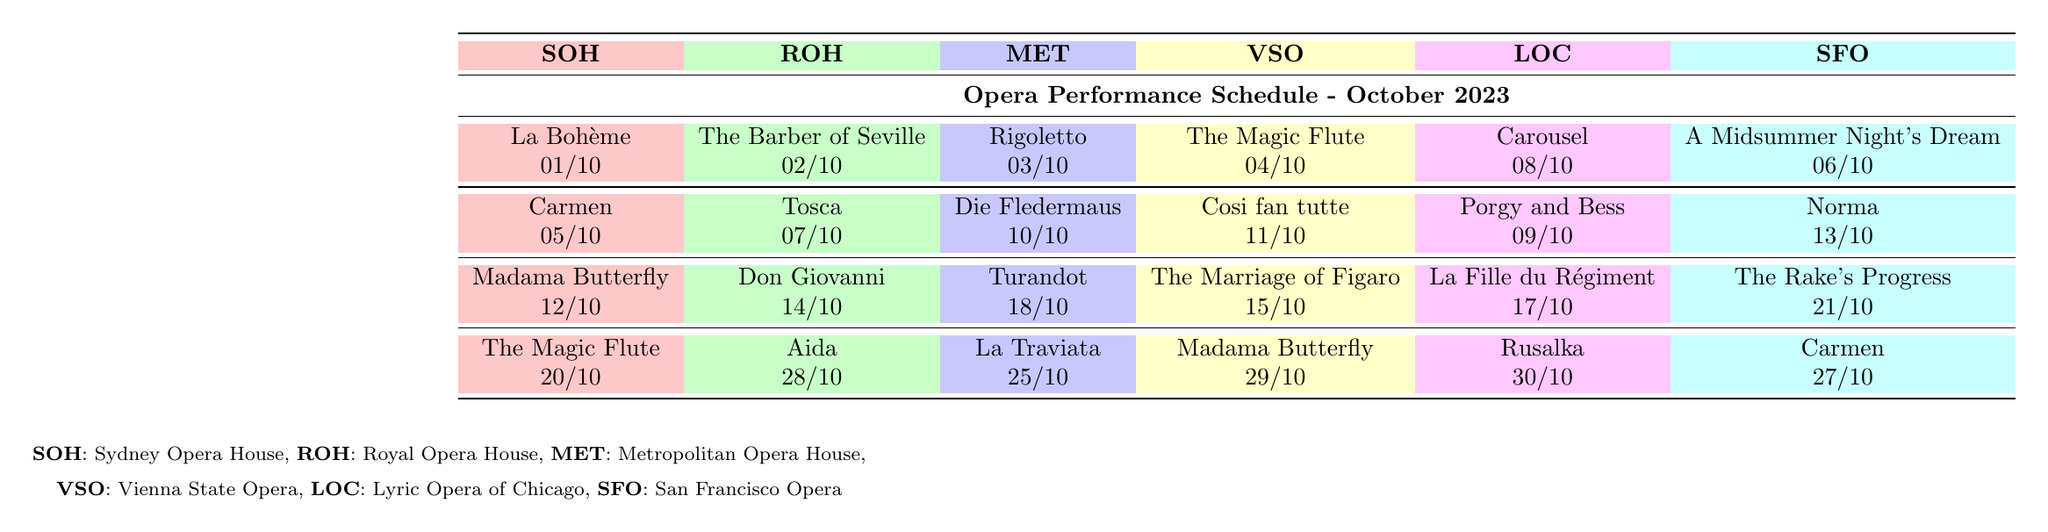What is the first performance at the Sydney Opera House in October 2023? The first performance listed for the Sydney Opera House is 'La Bohème' scheduled for October 1st.
Answer: La Bohème Which venue has a performance of 'Carmen' scheduled? 'Carmen' is scheduled at both the Sydney Opera House on October 5th and the San Francisco Opera on October 27th.
Answer: Sydney Opera House, San Francisco Opera On which date does the performance of 'Don Giovanni' take place? The performance 'Don Giovanni' is scheduled for October 14th at the Royal Opera House, as stated in the performance schedule.
Answer: October 14th How many performances are scheduled at the Vienna State Opera in October? The Vienna State Opera has four performances scheduled in October: 'The Magic Flute', 'Cosi fan tutte', 'The Marriage of Figaro', and 'Madama Butterfly'.
Answer: Four Which opera venue has the latest performance in October 2023? The latest performance is 'Aida' at the Royal Opera House on October 28th. It is checked by looking at the dates across each venue’s performance schedule.
Answer: Royal Opera House What performances are taking place on October 10th? On October 10th, the Metropolitan Opera House is hosting 'Die Fledermaus', and the Lyric Opera of Chicago is having 'Porgy and Bess'.
Answer: Die Fledermaus, Porgy and Bess Is 'Rusalka' performed more than once in October? 'Rusalka' is only scheduled for one performance on October 30th at the Lyric Opera of Chicago, so the statement is false.
Answer: No How many performances are there in total across all venues in October? By adding the performances from each venue (4 performances each for 6 venues), the total is 24 performances (4 x 6 = 24).
Answer: 24 Which two venues are performing 'Madama Butterfly' in October? 'Madama Butterfly' is scheduled at the Sydney Opera House on October 12th and the Vienna State Opera on October 29th, as seen in the performance schedules.
Answer: Sydney Opera House, Vienna State Opera 